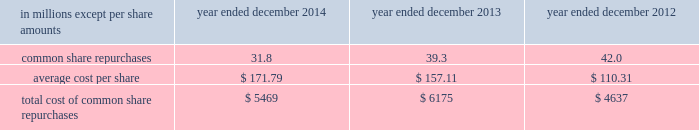Notes to consolidated financial statements guarantees of subsidiaries .
Group inc .
Fully and unconditionally guarantees the securities issued by gs finance corp. , a wholly-owned finance subsidiary of the group inc .
Has guaranteed the payment obligations of goldman , sachs & co .
( gs&co. ) , gs bank usa and goldman sachs execution & clearing , l.p .
( gsec ) , subject to certain exceptions .
In november 2008 , the firm contributed subsidiaries into gs bank usa , and group inc .
Agreed to guarantee the reimbursement of certain losses , including credit-related losses , relating to assets held by the contributed entities .
In connection with this guarantee , group inc .
Also agreed to pledge to gs bank usa certain collateral , including interests in subsidiaries and other illiquid assets .
In addition , group inc .
Guarantees many of the obligations of its other consolidated subsidiaries on a transaction-by- transaction basis , as negotiated with counterparties .
Group inc .
Is unable to develop an estimate of the maximum payout under its subsidiary guarantees ; however , because these guaranteed obligations are also obligations of consolidated subsidiaries , group inc . 2019s liabilities as guarantor are not separately disclosed .
Note 19 .
Shareholders 2019 equity common equity dividends declared per common share were $ 2.25 in 2014 , $ 2.05 in 2013 and $ 1.77 in 2012 .
On january 15 , 2015 , group inc .
Declared a dividend of $ 0.60 per common share to be paid on march 30 , 2015 to common shareholders of record on march 2 , 2015 .
The firm 2019s share repurchase program is intended to help maintain the appropriate level of common equity .
The share repurchase program is effected primarily through regular open-market purchases ( which may include repurchase plans designed to comply with rule 10b5-1 ) , the amounts and timing of which are determined primarily by the firm 2019s current and projected capital position , but which may also be influenced by general market conditions and the prevailing price and trading volumes of the firm 2019s common stock .
Prior to repurchasing common stock , the firm must receive confirmation that the federal reserve board does not object to such capital actions .
The table below presents the amount of common stock repurchased by the firm under the share repurchase program during 2014 , 2013 and 2012. .
Total cost of common share repurchases $ 5469 $ 6175 $ 4637 pursuant to the terms of certain share-based compensation plans , employees may remit shares to the firm or the firm may cancel restricted stock units ( rsus ) or stock options to satisfy minimum statutory employee tax withholding requirements and the exercise price of stock options .
Under these plans , during 2014 , 2013 and 2012 , employees remitted 174489 shares , 161211 shares and 33477 shares with a total value of $ 31 million , $ 25 million and $ 3 million , and the firm cancelled 5.8 million , 4.0 million and 12.7 million of rsus with a total value of $ 974 million , $ 599 million and $ 1.44 billion .
Under these plans , the firm also cancelled 15.6 million stock options with a total value of $ 2.65 billion during 2014 .
170 goldman sachs 2014 annual report .
In millions for 2014 2013 and 2012 , what was the greatest amount of common share repurchases? 
Computations: table_max(common share repurchases, none)
Answer: 42.0. 